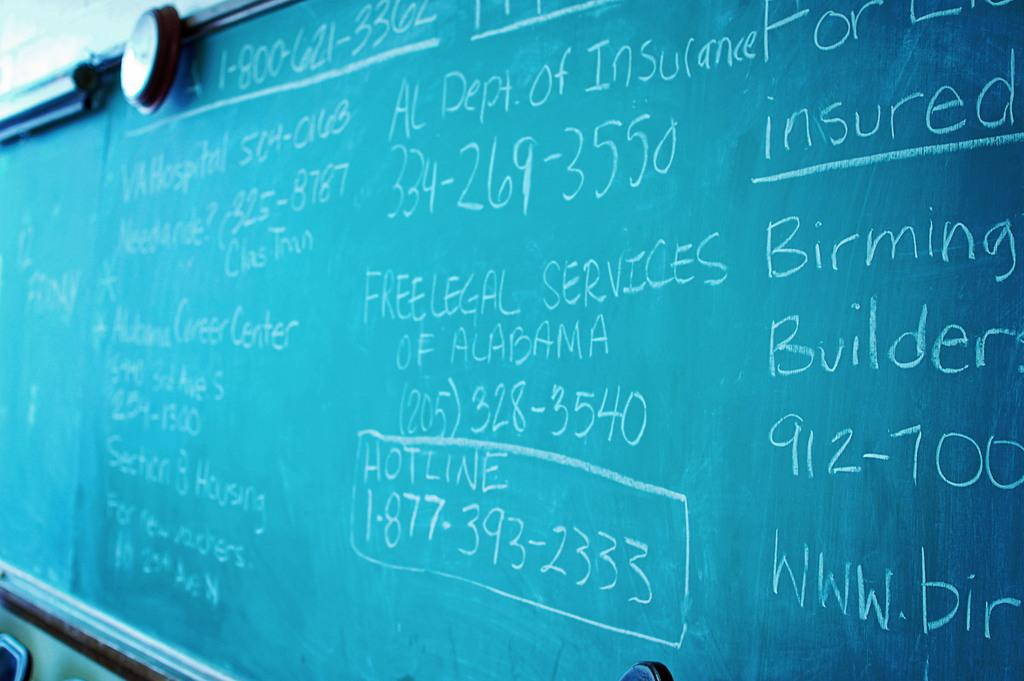Provide a one-sentence caption for the provided image. A chalkboard with info such as Free Legal Services of Alabama. 